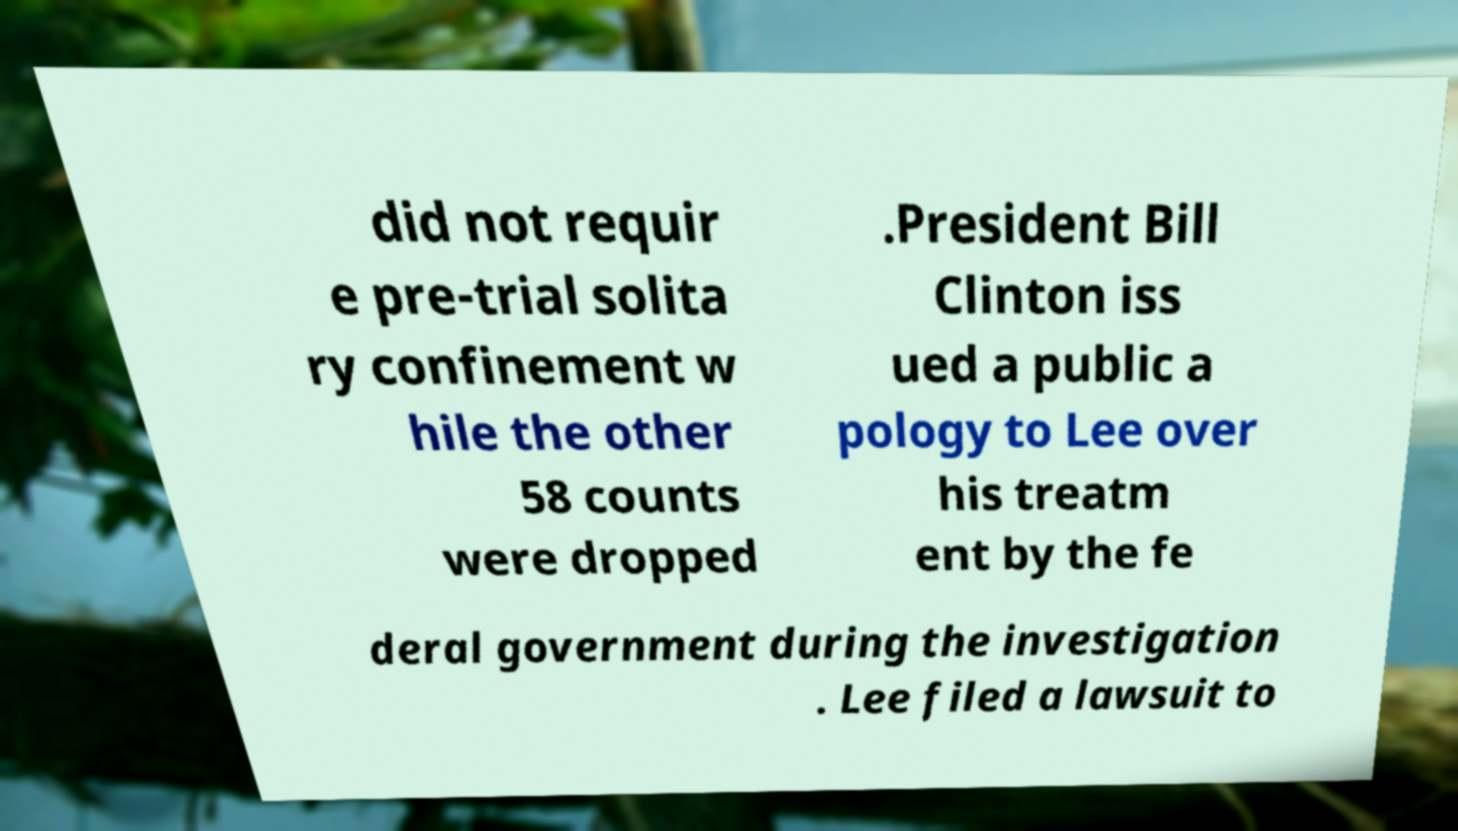I need the written content from this picture converted into text. Can you do that? did not requir e pre-trial solita ry confinement w hile the other 58 counts were dropped .President Bill Clinton iss ued a public a pology to Lee over his treatm ent by the fe deral government during the investigation . Lee filed a lawsuit to 